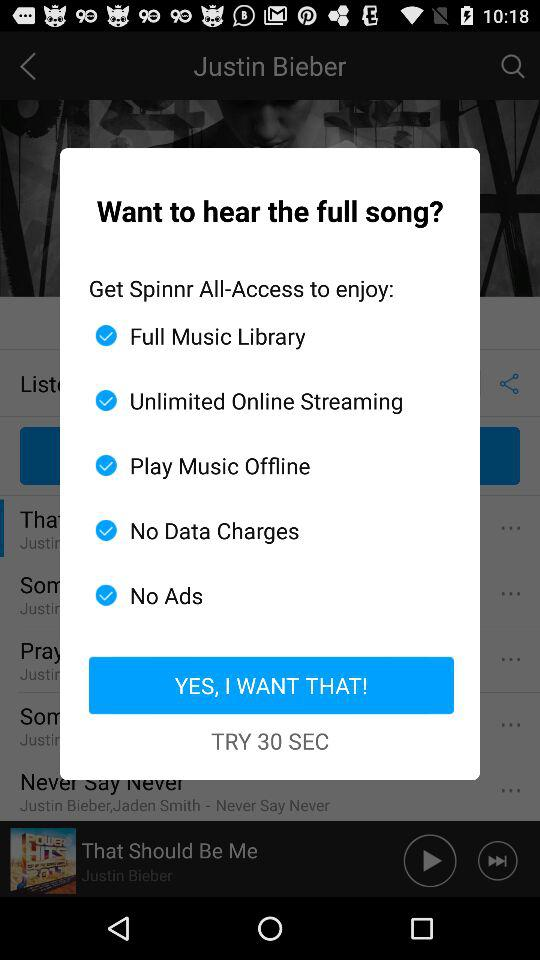How many more features are available with Spinnr All-Access than with the free version?
Answer the question using a single word or phrase. 5 